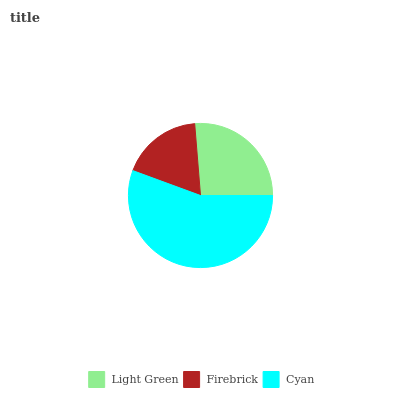Is Firebrick the minimum?
Answer yes or no. Yes. Is Cyan the maximum?
Answer yes or no. Yes. Is Cyan the minimum?
Answer yes or no. No. Is Firebrick the maximum?
Answer yes or no. No. Is Cyan greater than Firebrick?
Answer yes or no. Yes. Is Firebrick less than Cyan?
Answer yes or no. Yes. Is Firebrick greater than Cyan?
Answer yes or no. No. Is Cyan less than Firebrick?
Answer yes or no. No. Is Light Green the high median?
Answer yes or no. Yes. Is Light Green the low median?
Answer yes or no. Yes. Is Firebrick the high median?
Answer yes or no. No. Is Cyan the low median?
Answer yes or no. No. 